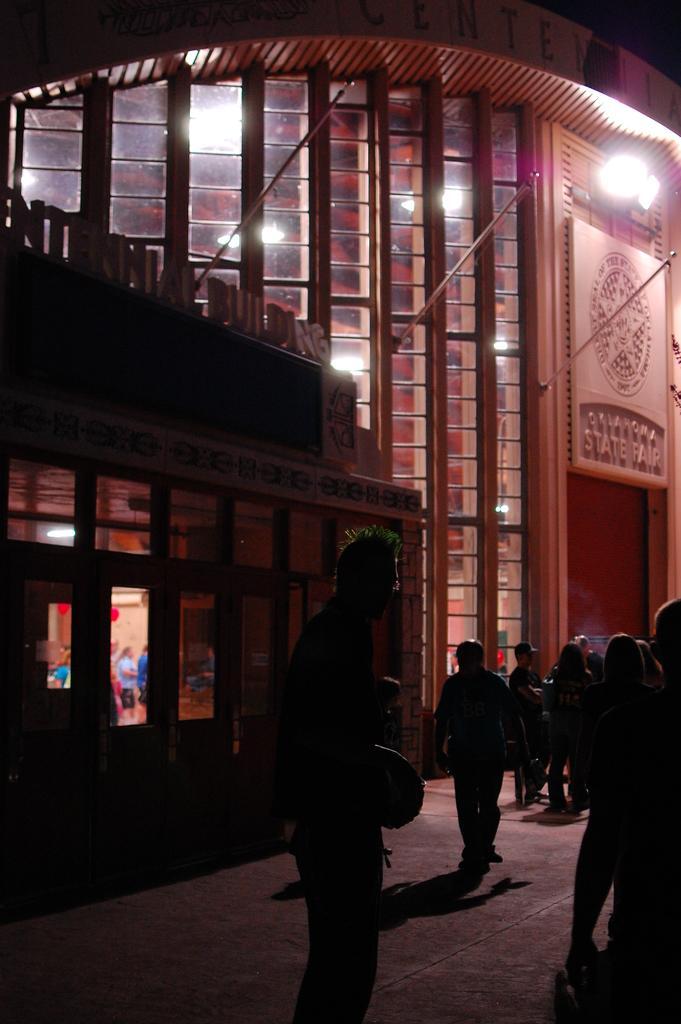Describe this image in one or two sentences. This image is taken outdoors. At the bottom of the image there is a floor. On the right side of the image a few people are standing on the floor. In the background there are two buildings with walls, windows and roofs. There are two boards with text on them and there is a light. 